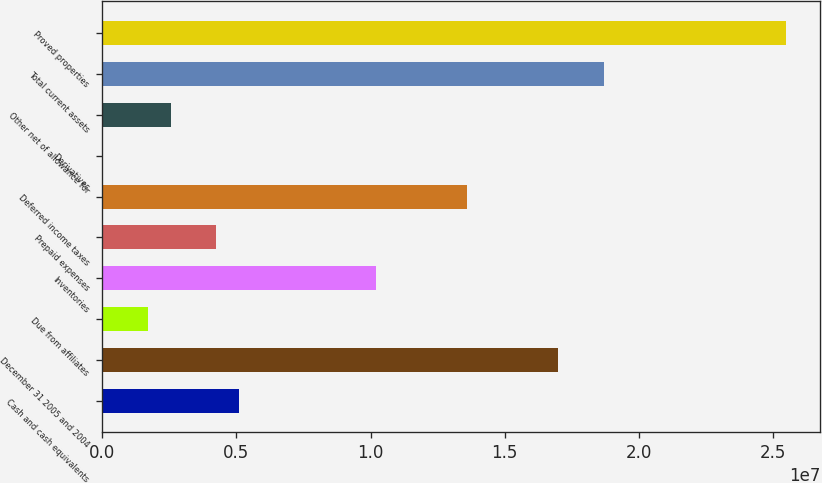<chart> <loc_0><loc_0><loc_500><loc_500><bar_chart><fcel>Cash and cash equivalents<fcel>December 31 2005 and 2004<fcel>Due from affiliates<fcel>Inventories<fcel>Prepaid expenses<fcel>Deferred income taxes<fcel>Derivatives<fcel>Other net of allowance for<fcel>Total current assets<fcel>Proved properties<nl><fcel>5.10005e+06<fcel>1.69973e+07<fcel>1.70085e+06<fcel>1.01989e+07<fcel>4.25025e+06<fcel>1.35981e+07<fcel>1246<fcel>2.55065e+06<fcel>1.86969e+07<fcel>2.54953e+07<nl></chart> 